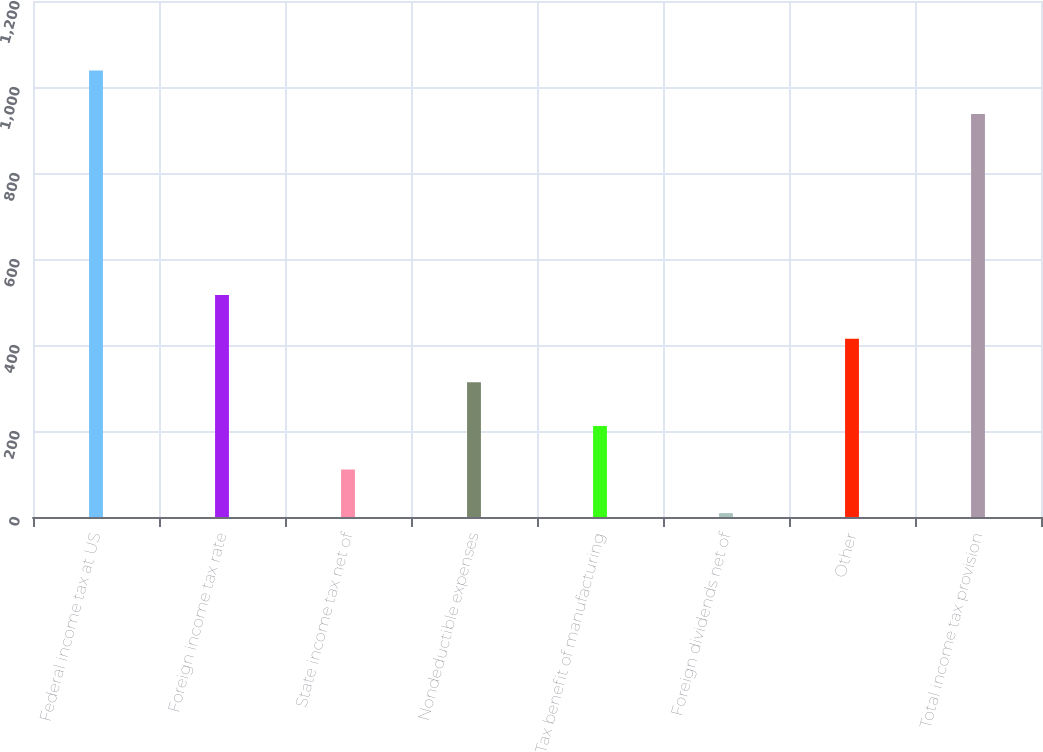Convert chart. <chart><loc_0><loc_0><loc_500><loc_500><bar_chart><fcel>Federal income tax at US<fcel>Foreign income tax rate<fcel>State income tax net of<fcel>Nondeductible expenses<fcel>Tax benefit of manufacturing<fcel>Foreign dividends net of<fcel>Other<fcel>Total income tax provision<nl><fcel>1038.4<fcel>516<fcel>110.4<fcel>313.2<fcel>211.8<fcel>9<fcel>414.6<fcel>937<nl></chart> 